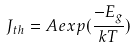Convert formula to latex. <formula><loc_0><loc_0><loc_500><loc_500>J _ { t h } = A e x p ( \frac { - E _ { g } } { k T } )</formula> 